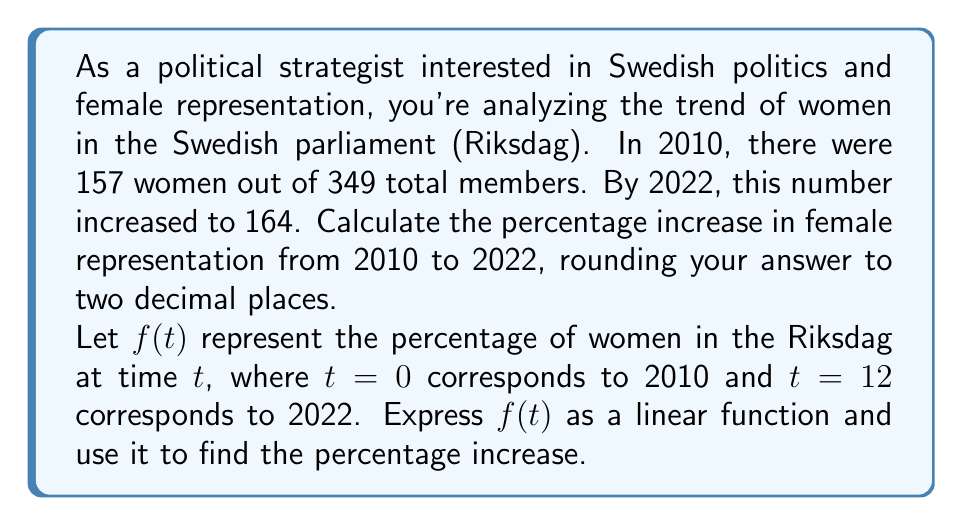Teach me how to tackle this problem. To solve this problem, we'll follow these steps:

1) Calculate the percentages for 2010 and 2022:

   2010 (t=0): $f(0) = \frac{157}{349} \times 100\% \approx 44.99\%$
   2022 (t=12): $f(12) = \frac{164}{349} \times 100\% \approx 46.99\%$

2) Express $f(t)$ as a linear function:
   $f(t) = mt + b$, where $m$ is the slope and $b$ is the y-intercept.

3) Calculate the slope:
   $m = \frac{f(12) - f(0)}{12 - 0} = \frac{46.99\% - 44.99\%}{12} \approx 0.1667\%$ per year

4) Find $b$ using the point (0, 44.99):
   $44.99 = m(0) + b$, so $b = 44.99$

5) Therefore, $f(t) = 0.1667t + 44.99$

6) Calculate the percentage increase:
   Percentage increase = $\frac{f(12) - f(0)}{f(0)} \times 100\%$
   $= \frac{46.99\% - 44.99\%}{44.99\%} \times 100\% \approx 4.45\%$
Answer: The percentage increase in female representation in the Swedish parliament from 2010 to 2022 is approximately 4.45%. 